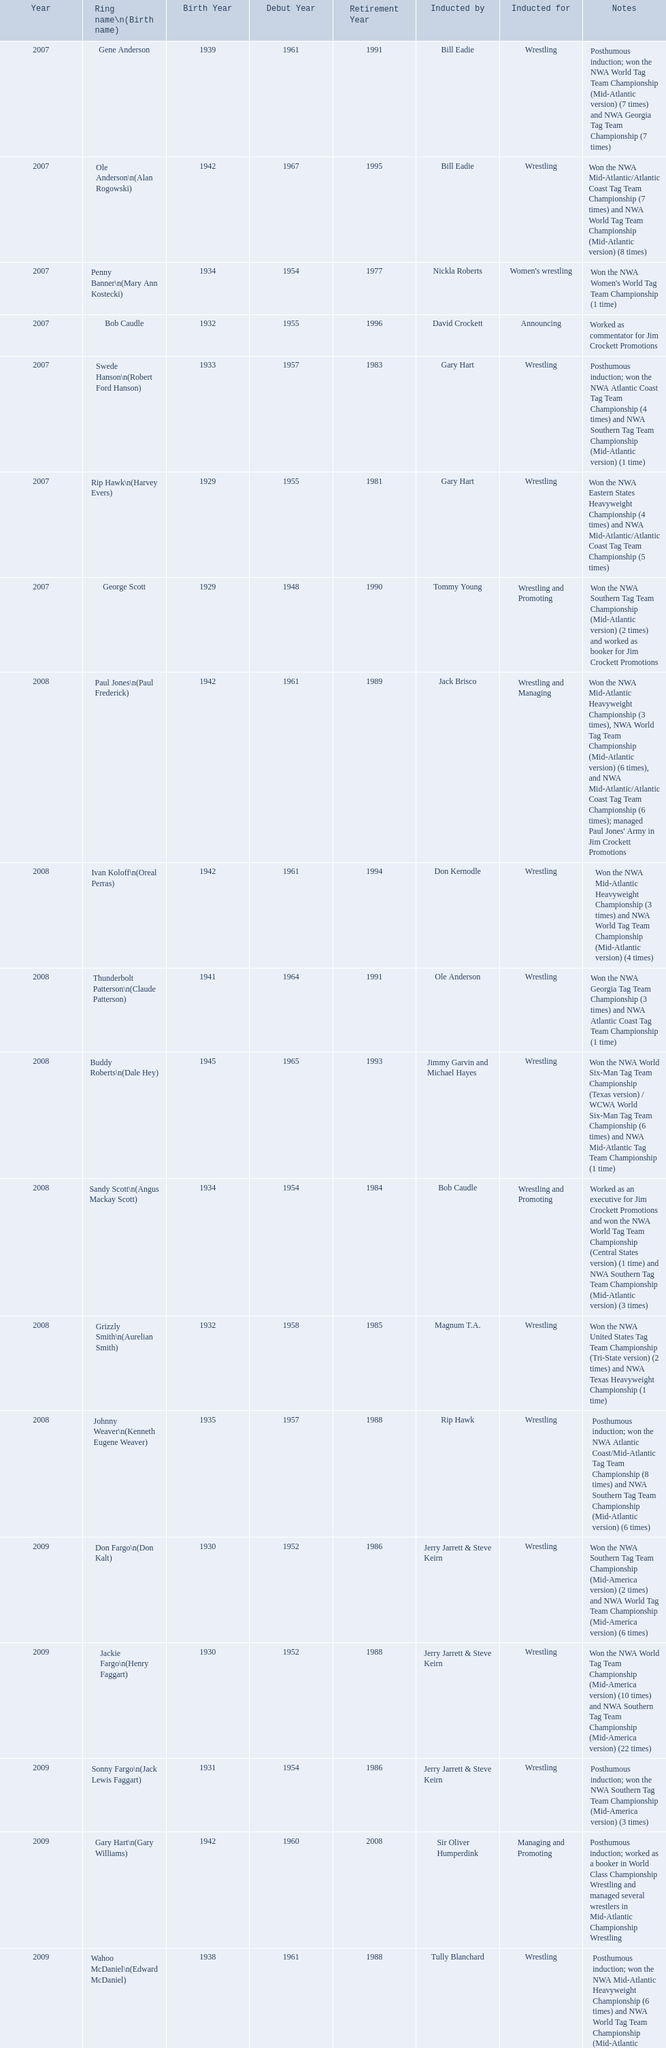What were the names of the inductees in 2007? Gene Anderson, Ole Anderson\n(Alan Rogowski), Penny Banner\n(Mary Ann Kostecki), Bob Caudle, Swede Hanson\n(Robert Ford Hanson), Rip Hawk\n(Harvey Evers), George Scott. Of the 2007 inductees, which were posthumous? Gene Anderson, Swede Hanson\n(Robert Ford Hanson). Besides swede hanson, what other 2007 inductee was not living at the time of induction? Gene Anderson. What year was the induction held? 2007. Which inductee was not alive? Gene Anderson. 